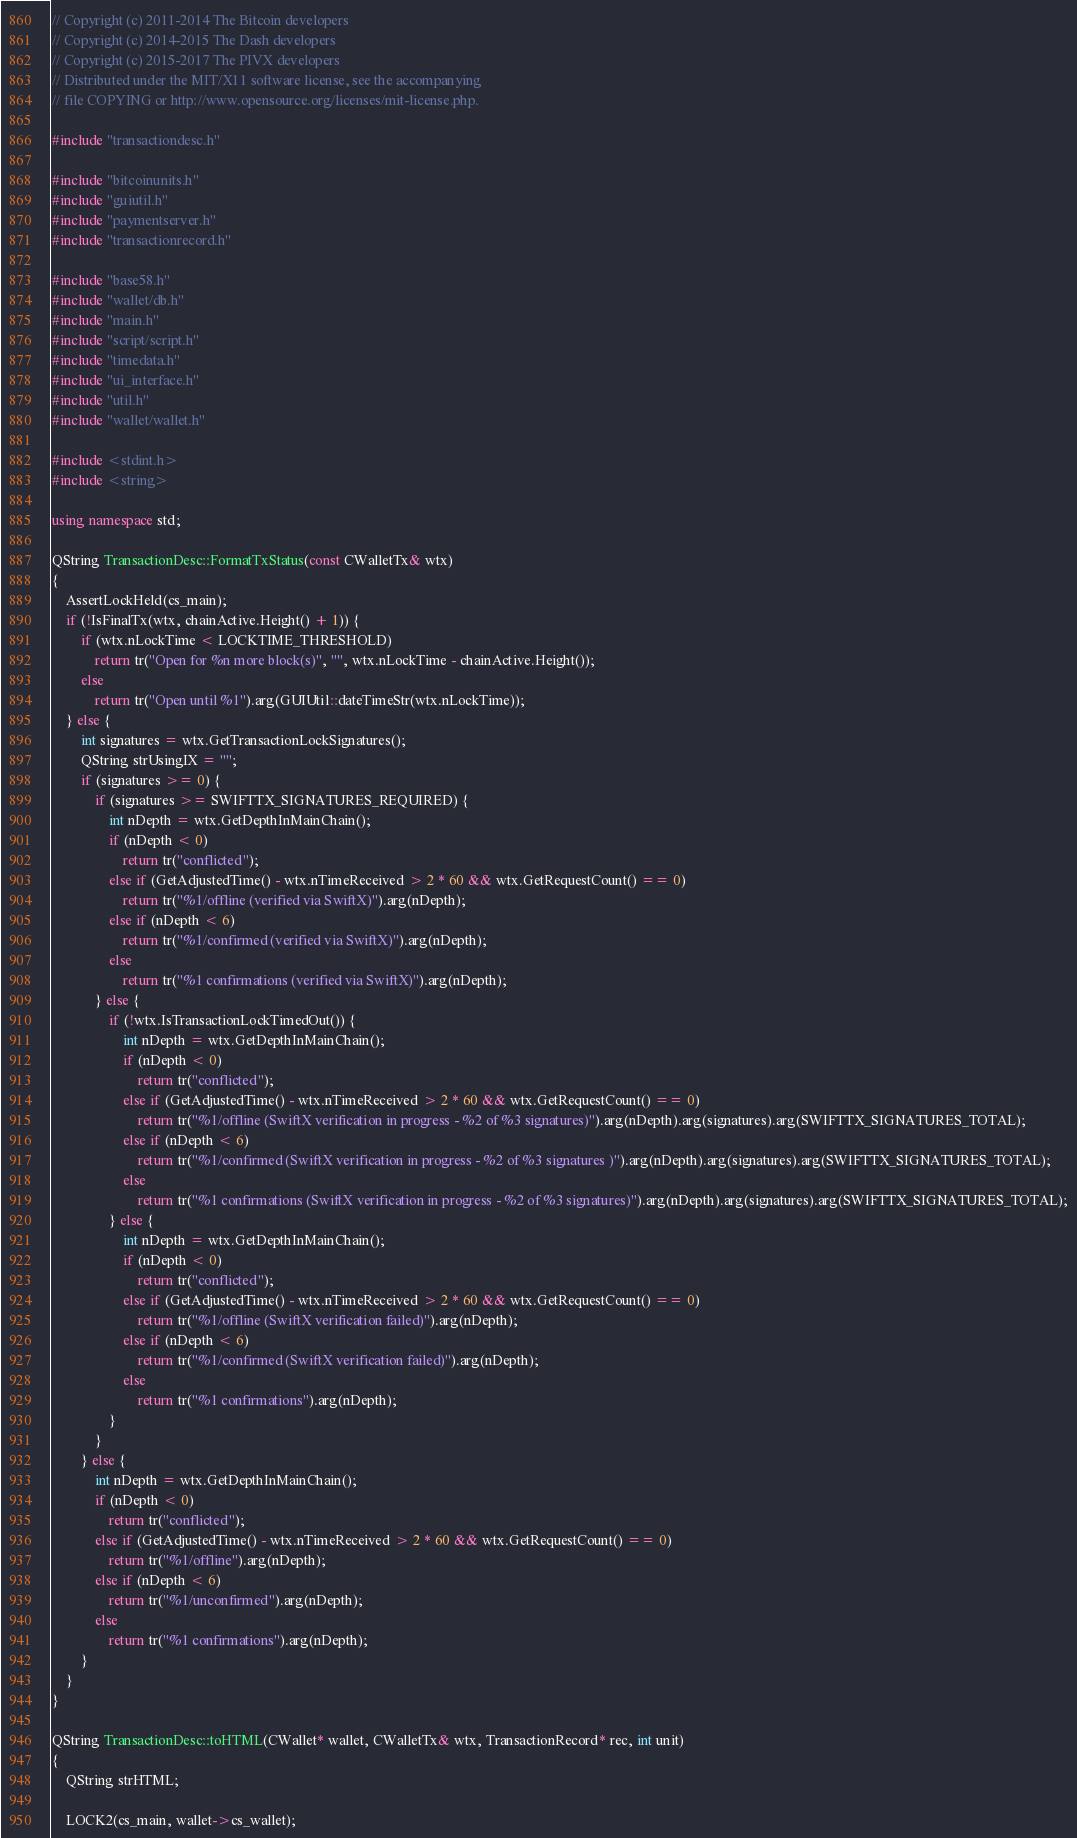<code> <loc_0><loc_0><loc_500><loc_500><_C++_>// Copyright (c) 2011-2014 The Bitcoin developers
// Copyright (c) 2014-2015 The Dash developers
// Copyright (c) 2015-2017 The PIVX developers
// Distributed under the MIT/X11 software license, see the accompanying
// file COPYING or http://www.opensource.org/licenses/mit-license.php.

#include "transactiondesc.h"

#include "bitcoinunits.h"
#include "guiutil.h"
#include "paymentserver.h"
#include "transactionrecord.h"

#include "base58.h"
#include "wallet/db.h"
#include "main.h"
#include "script/script.h"
#include "timedata.h"
#include "ui_interface.h"
#include "util.h"
#include "wallet/wallet.h"

#include <stdint.h>
#include <string>

using namespace std;

QString TransactionDesc::FormatTxStatus(const CWalletTx& wtx)
{
    AssertLockHeld(cs_main);
    if (!IsFinalTx(wtx, chainActive.Height() + 1)) {
        if (wtx.nLockTime < LOCKTIME_THRESHOLD)
            return tr("Open for %n more block(s)", "", wtx.nLockTime - chainActive.Height());
        else
            return tr("Open until %1").arg(GUIUtil::dateTimeStr(wtx.nLockTime));
    } else {
        int signatures = wtx.GetTransactionLockSignatures();
        QString strUsingIX = "";
        if (signatures >= 0) {
            if (signatures >= SWIFTTX_SIGNATURES_REQUIRED) {
                int nDepth = wtx.GetDepthInMainChain();
                if (nDepth < 0)
                    return tr("conflicted");
                else if (GetAdjustedTime() - wtx.nTimeReceived > 2 * 60 && wtx.GetRequestCount() == 0)
                    return tr("%1/offline (verified via SwiftX)").arg(nDepth);
                else if (nDepth < 6)
                    return tr("%1/confirmed (verified via SwiftX)").arg(nDepth);
                else
                    return tr("%1 confirmations (verified via SwiftX)").arg(nDepth);
            } else {
                if (!wtx.IsTransactionLockTimedOut()) {
                    int nDepth = wtx.GetDepthInMainChain();
                    if (nDepth < 0)
                        return tr("conflicted");
                    else if (GetAdjustedTime() - wtx.nTimeReceived > 2 * 60 && wtx.GetRequestCount() == 0)
                        return tr("%1/offline (SwiftX verification in progress - %2 of %3 signatures)").arg(nDepth).arg(signatures).arg(SWIFTTX_SIGNATURES_TOTAL);
                    else if (nDepth < 6)
                        return tr("%1/confirmed (SwiftX verification in progress - %2 of %3 signatures )").arg(nDepth).arg(signatures).arg(SWIFTTX_SIGNATURES_TOTAL);
                    else
                        return tr("%1 confirmations (SwiftX verification in progress - %2 of %3 signatures)").arg(nDepth).arg(signatures).arg(SWIFTTX_SIGNATURES_TOTAL);
                } else {
                    int nDepth = wtx.GetDepthInMainChain();
                    if (nDepth < 0)
                        return tr("conflicted");
                    else if (GetAdjustedTime() - wtx.nTimeReceived > 2 * 60 && wtx.GetRequestCount() == 0)
                        return tr("%1/offline (SwiftX verification failed)").arg(nDepth);
                    else if (nDepth < 6)
                        return tr("%1/confirmed (SwiftX verification failed)").arg(nDepth);
                    else
                        return tr("%1 confirmations").arg(nDepth);
                }
            }
        } else {
            int nDepth = wtx.GetDepthInMainChain();
            if (nDepth < 0)
                return tr("conflicted");
            else if (GetAdjustedTime() - wtx.nTimeReceived > 2 * 60 && wtx.GetRequestCount() == 0)
                return tr("%1/offline").arg(nDepth);
            else if (nDepth < 6)
                return tr("%1/unconfirmed").arg(nDepth);
            else
                return tr("%1 confirmations").arg(nDepth);
        }
    }
}

QString TransactionDesc::toHTML(CWallet* wallet, CWalletTx& wtx, TransactionRecord* rec, int unit)
{
    QString strHTML;

    LOCK2(cs_main, wallet->cs_wallet);</code> 